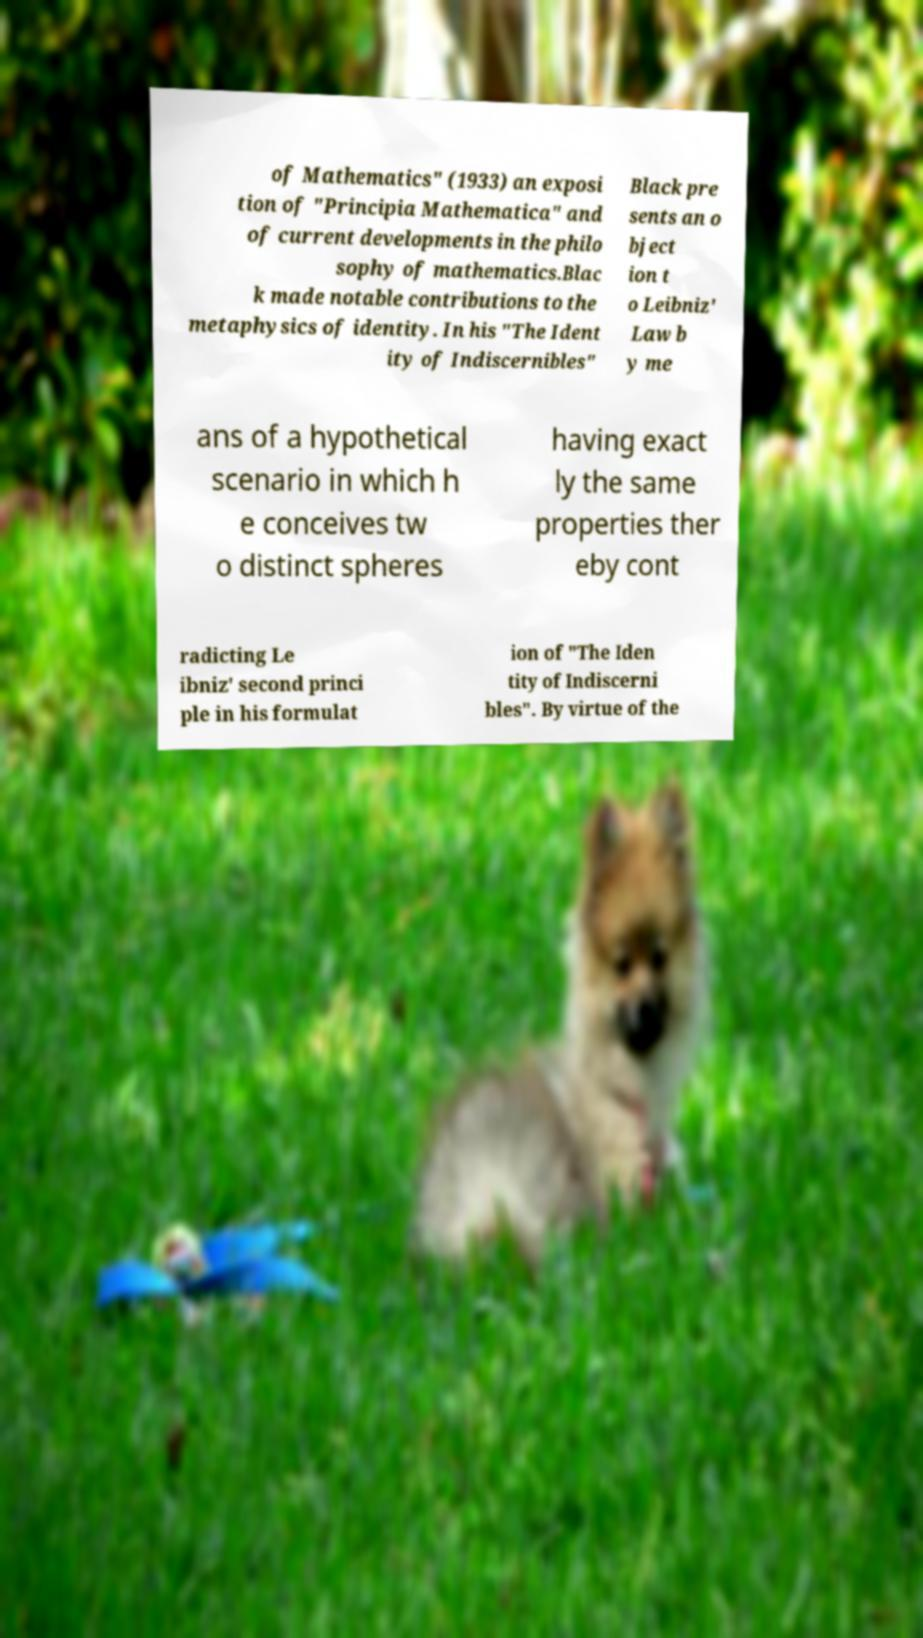I need the written content from this picture converted into text. Can you do that? of Mathematics" (1933) an exposi tion of "Principia Mathematica" and of current developments in the philo sophy of mathematics.Blac k made notable contributions to the metaphysics of identity. In his "The Ident ity of Indiscernibles" Black pre sents an o bject ion t o Leibniz' Law b y me ans of a hypothetical scenario in which h e conceives tw o distinct spheres having exact ly the same properties ther eby cont radicting Le ibniz' second princi ple in his formulat ion of "The Iden tity of Indiscerni bles". By virtue of the 